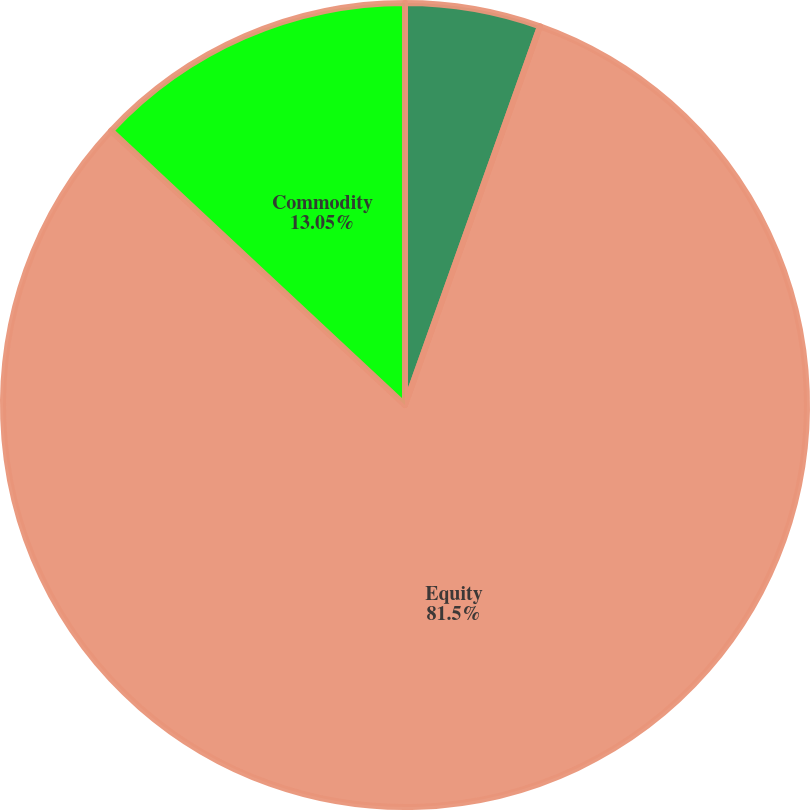Convert chart. <chart><loc_0><loc_0><loc_500><loc_500><pie_chart><fcel>Foreign exchange<fcel>Equity<fcel>Commodity<nl><fcel>5.45%<fcel>81.5%<fcel>13.05%<nl></chart> 